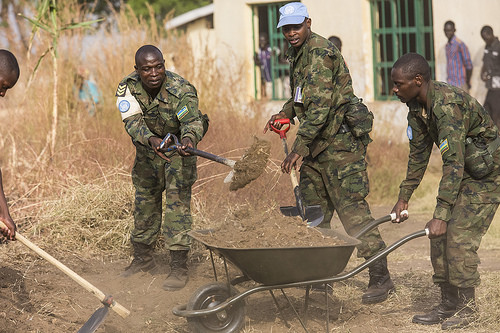<image>
Is the soldier to the left of the soldier? Yes. From this viewpoint, the soldier is positioned to the left side relative to the soldier. Is the wall behind the man? Yes. From this viewpoint, the wall is positioned behind the man, with the man partially or fully occluding the wall. 